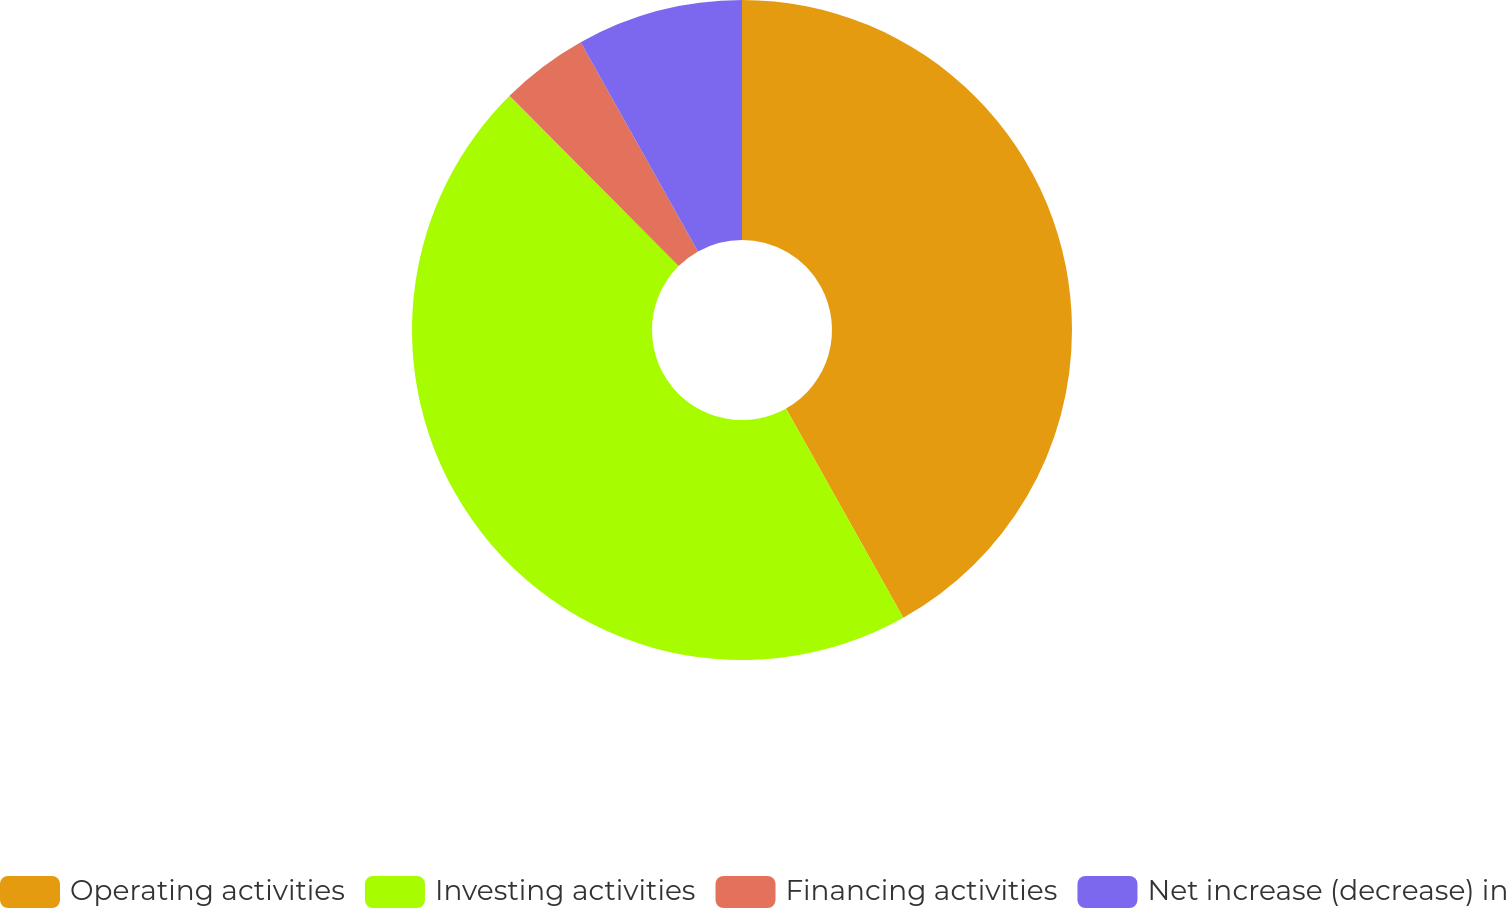<chart> <loc_0><loc_0><loc_500><loc_500><pie_chart><fcel>Operating activities<fcel>Investing activities<fcel>Financing activities<fcel>Net increase (decrease) in<nl><fcel>41.87%<fcel>45.69%<fcel>4.31%<fcel>8.13%<nl></chart> 